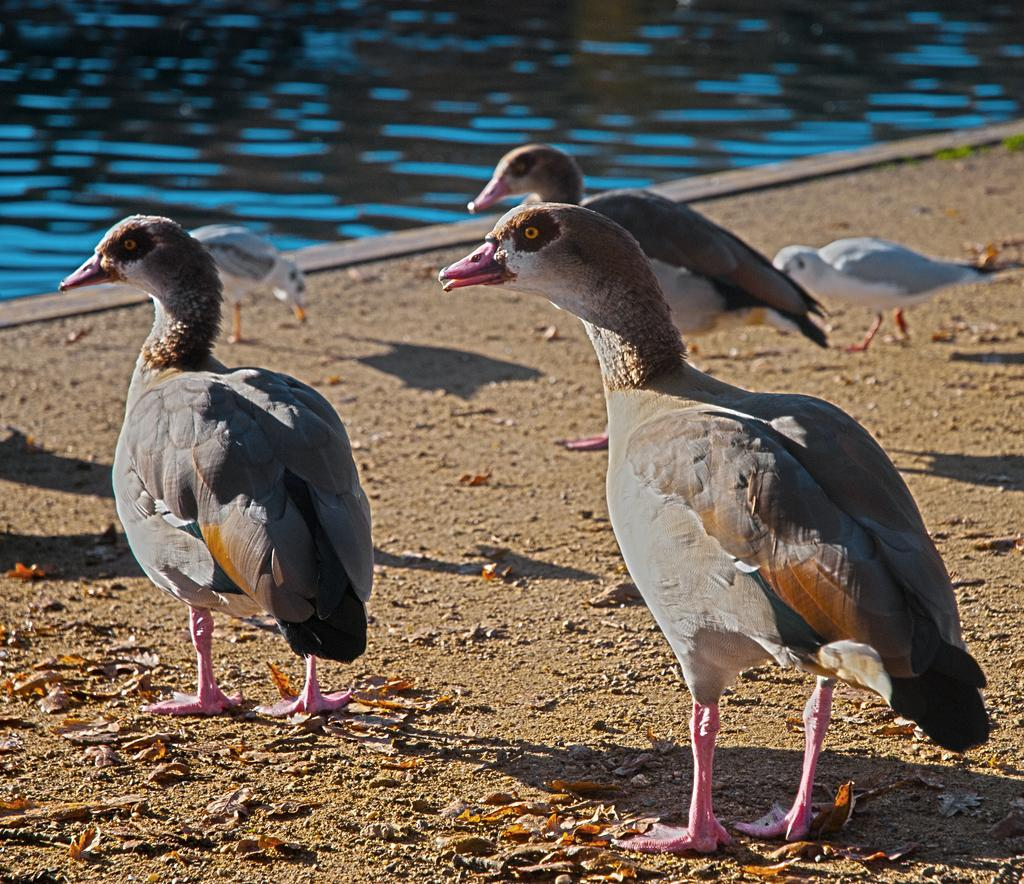What type of animals can be seen in the image? Birds can be seen in the image. What is visible in the background of the image? There is water visible in the background of the image. What type of lock is used to secure the news in the image? There is no lock or news present in the image; it features birds and water. 